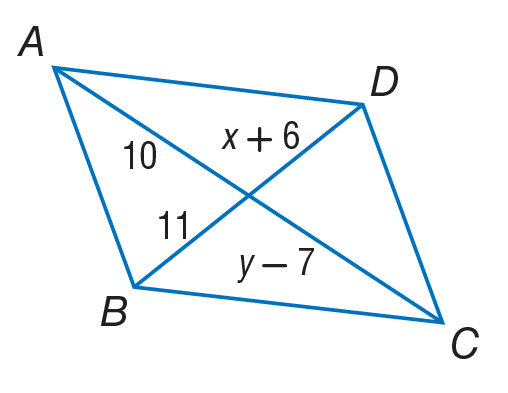Answer the mathemtical geometry problem and directly provide the correct option letter.
Question: Use parallelogram to, find x.
Choices: A: 5 B: 10 C: 11 D: 17 A 